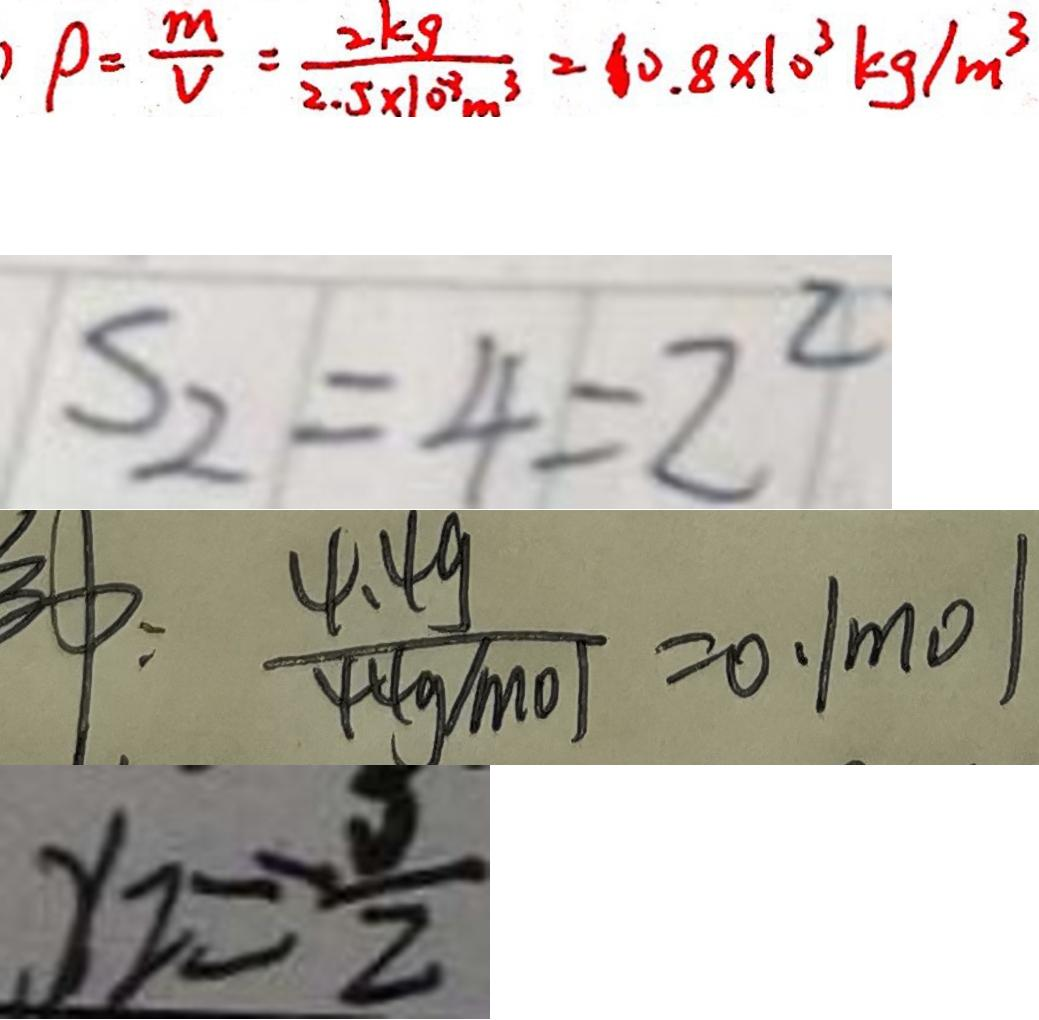<formula> <loc_0><loc_0><loc_500><loc_500>P = \frac { m } { V } = \frac { 2 k g } { 2 . 5 \times 1 0 ^ { 8 } m ^ { 3 } } = 1 0 . 8 \times 1 0 ^ { 3 } k g / m ^ { 3 } 
 S _ { 2 } = 4 = 2 ^ { 2 } 
 : \frac { 4 . 4 9 } { 4 4 g / m o / } = 0 . 1 m o l 
 y _ { 2 } = - \frac { 5 } { 2 }</formula> 